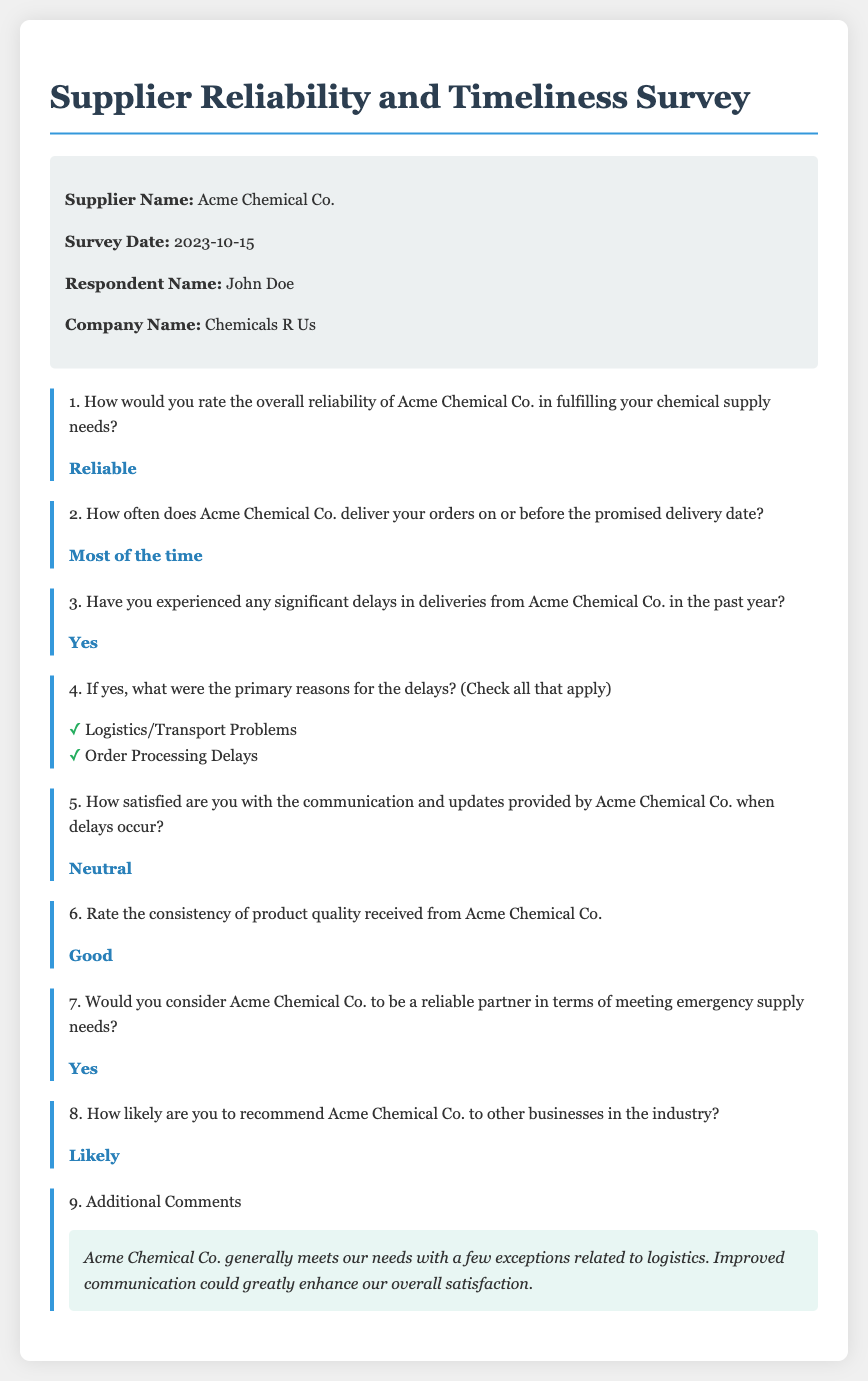What is the name of the supplier? The document lists the supplier's name as Acme Chemical Co.
Answer: Acme Chemical Co What is the date of the survey? The survey is dated October 15, 2023, as mentioned in the document.
Answer: 2023-10-15 Who is the respondent? The document indicates the respondent's name as John Doe.
Answer: John Doe What rating did the respondent give for the overall reliability? The response to the reliability of Acme Chemical Co. is "Reliable."
Answer: Reliable How often does Acme Chemical Co. deliver on time? According to the document, the response states they deliver "Most of the time."
Answer: Most of the time What were the reasons for delays according to the respondent? The delays were related to "Logistics/Transport Problems" and "Order Processing Delays."
Answer: Logistics/Transport Problems, Order Processing Delays How satisfied is the respondent with the communication when delays occur? The respondent rated their satisfaction with communication as "Neutral."
Answer: Neutral What is the quality rating of the products received? The document states the consistency of product quality received is rated as "Good."
Answer: Good How likely is the respondent to recommend Acme Chemical Co.? The document indicates the likelihood of recommendation as "Likely."
Answer: Likely 